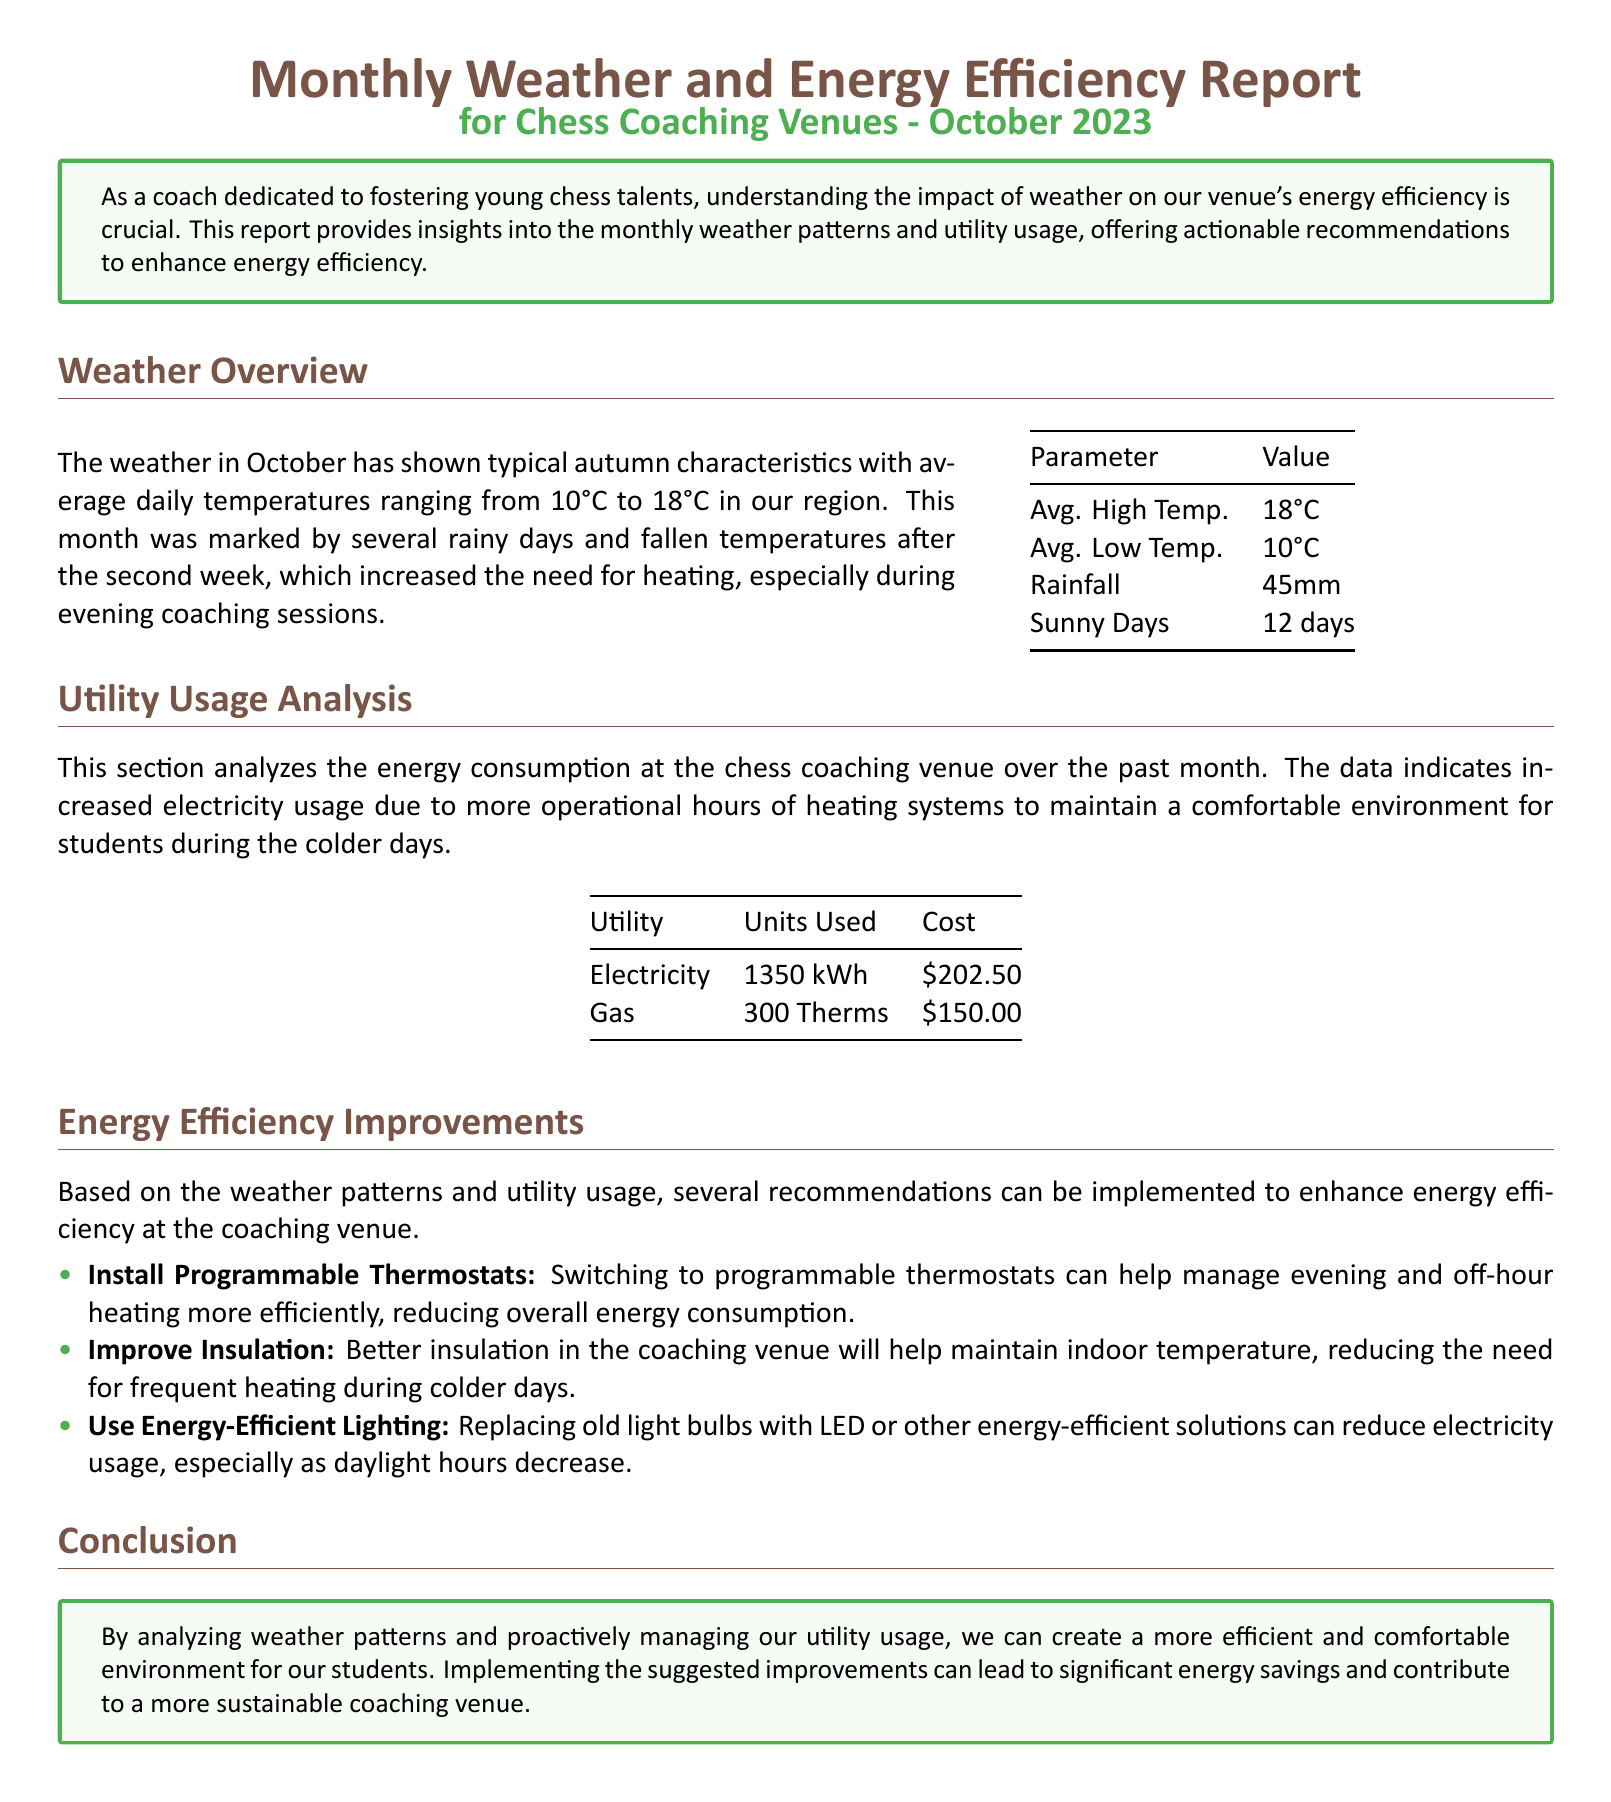What was the average high temperature in October? The document states that the average high temperature was 18°C in October.
Answer: 18°C How many rainy days were there in October? The report mentions there were several rainy days, indicating 45mm of rainfall, which typically corresponds to multiple rainy days.
Answer: Several rainy days What was the cost of electricity used? The costs associated with utility usage show that the electricity cost for the month was $202.50.
Answer: $202.50 What energy-efficient lighting is suggested in the report? The document recommends replacing old light bulbs with LED or other energy-efficient solutions for lighting.
Answer: LED Why has electricity usage increased at the venue? The increase in electricity usage is attributed to more operational hours of heating systems due to colder weather.
Answer: Heating systems What is the total gas usage for the month? The utility analysis in the report specifies that gas usage amounted to 300 Therms for the month.
Answer: 300 Therms How many sunny days were recorded in October? The document indicates that there were 12 sunny days in October.
Answer: 12 days What improvement is suggested for temperature management? The report recommends installing programmable thermostats to manage heating more efficiently.
Answer: Programmable thermostats What is the total rainfall recorded in October? The document states the total rainfall for October was 45mm.
Answer: 45mm 